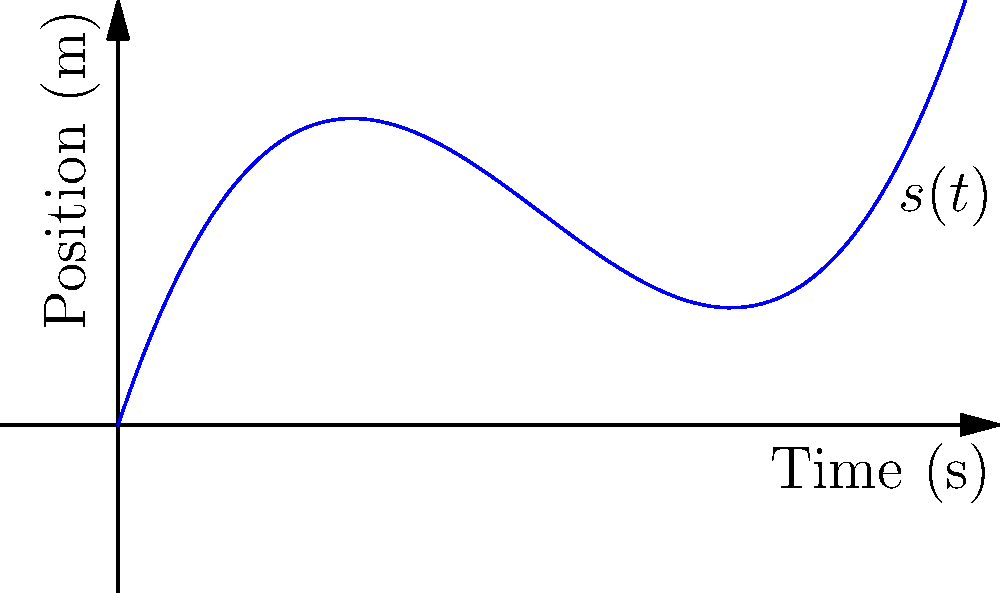The position-time graph of a wide receiver's sprint is given by the function $s(t) = 0.05t^3 - 0.75t^2 + 3t$, where $s$ is the position in meters and $t$ is the time in seconds. At what time(s) during the first 10 seconds of the sprint does the wide receiver experience zero acceleration? To find when the acceleration is zero, we need to follow these steps:

1) First, recall that acceleration is the second derivative of position with respect to time.

2) Let's find the velocity function (first derivative):
   $v(t) = s'(t) = 0.15t^2 - 1.5t + 3$

3) Now, let's find the acceleration function (second derivative):
   $a(t) = v'(t) = s''(t) = 0.3t - 1.5$

4) To find when acceleration is zero, we set $a(t) = 0$:
   $0.3t - 1.5 = 0$

5) Solve this equation:
   $0.3t = 1.5$
   $t = 5$

6) We need to check if this time (5 seconds) is within the given range of 0-10 seconds. It is, so this is our answer.

Therefore, the wide receiver experiences zero acceleration at 5 seconds into the sprint.
Answer: 5 seconds 